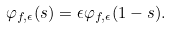Convert formula to latex. <formula><loc_0><loc_0><loc_500><loc_500>\varphi _ { f , \epsilon } ( s ) = \epsilon \varphi _ { f , \epsilon } ( 1 - s ) .</formula> 